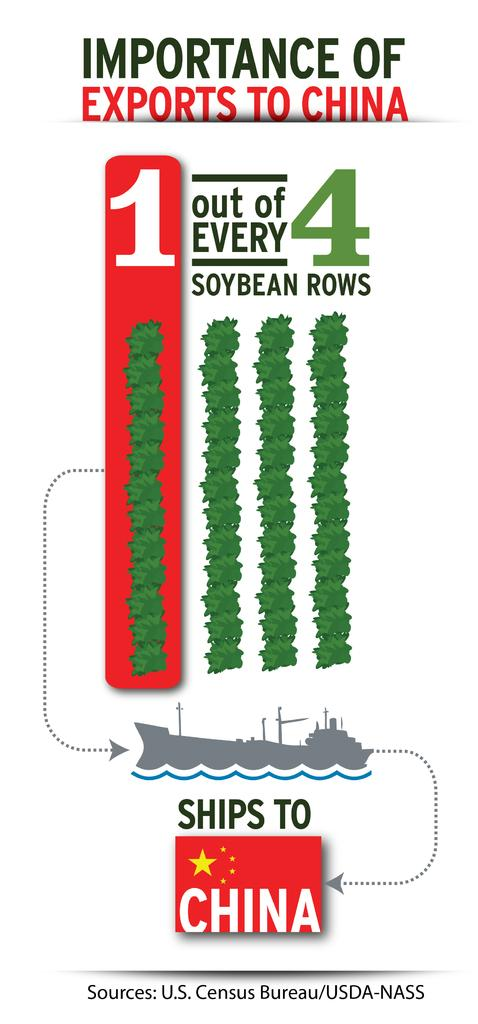<image>
Summarize the visual content of the image. The poster explains about the amount of soybeans are exported to China. 